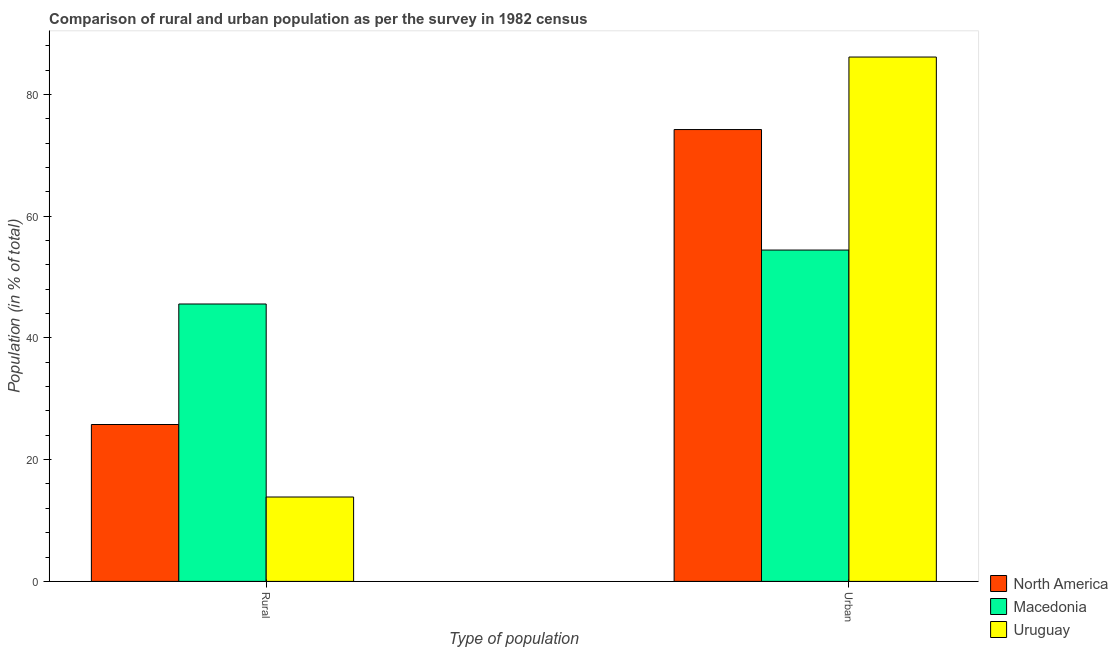How many different coloured bars are there?
Your response must be concise. 3. How many groups of bars are there?
Ensure brevity in your answer.  2. Are the number of bars on each tick of the X-axis equal?
Make the answer very short. Yes. How many bars are there on the 1st tick from the right?
Provide a succinct answer. 3. What is the label of the 1st group of bars from the left?
Your answer should be very brief. Rural. What is the rural population in Uruguay?
Keep it short and to the point. 13.86. Across all countries, what is the maximum rural population?
Offer a terse response. 45.57. Across all countries, what is the minimum rural population?
Provide a succinct answer. 13.86. In which country was the rural population maximum?
Your response must be concise. Macedonia. In which country was the rural population minimum?
Provide a short and direct response. Uruguay. What is the total urban population in the graph?
Make the answer very short. 214.8. What is the difference between the urban population in Uruguay and that in North America?
Offer a terse response. 11.91. What is the difference between the rural population in North America and the urban population in Uruguay?
Give a very brief answer. -60.37. What is the average urban population per country?
Provide a succinct answer. 71.6. What is the difference between the urban population and rural population in North America?
Provide a succinct answer. 48.45. What is the ratio of the urban population in North America to that in Macedonia?
Provide a succinct answer. 1.36. Is the urban population in Uruguay less than that in North America?
Offer a terse response. No. In how many countries, is the urban population greater than the average urban population taken over all countries?
Provide a succinct answer. 2. What does the 3rd bar from the left in Rural represents?
Offer a very short reply. Uruguay. What does the 3rd bar from the right in Urban represents?
Offer a very short reply. North America. How many bars are there?
Ensure brevity in your answer.  6. How many countries are there in the graph?
Provide a succinct answer. 3. Are the values on the major ticks of Y-axis written in scientific E-notation?
Offer a very short reply. No. Does the graph contain any zero values?
Give a very brief answer. No. How many legend labels are there?
Ensure brevity in your answer.  3. What is the title of the graph?
Ensure brevity in your answer.  Comparison of rural and urban population as per the survey in 1982 census. What is the label or title of the X-axis?
Provide a succinct answer. Type of population. What is the label or title of the Y-axis?
Offer a terse response. Population (in % of total). What is the Population (in % of total) in North America in Rural?
Offer a very short reply. 25.77. What is the Population (in % of total) in Macedonia in Rural?
Offer a terse response. 45.57. What is the Population (in % of total) of Uruguay in Rural?
Make the answer very short. 13.86. What is the Population (in % of total) in North America in Urban?
Your response must be concise. 74.23. What is the Population (in % of total) of Macedonia in Urban?
Give a very brief answer. 54.43. What is the Population (in % of total) in Uruguay in Urban?
Make the answer very short. 86.14. Across all Type of population, what is the maximum Population (in % of total) of North America?
Ensure brevity in your answer.  74.23. Across all Type of population, what is the maximum Population (in % of total) in Macedonia?
Provide a short and direct response. 54.43. Across all Type of population, what is the maximum Population (in % of total) in Uruguay?
Give a very brief answer. 86.14. Across all Type of population, what is the minimum Population (in % of total) in North America?
Provide a succinct answer. 25.77. Across all Type of population, what is the minimum Population (in % of total) in Macedonia?
Your answer should be very brief. 45.57. Across all Type of population, what is the minimum Population (in % of total) of Uruguay?
Your answer should be very brief. 13.86. What is the difference between the Population (in % of total) in North America in Rural and that in Urban?
Provide a succinct answer. -48.45. What is the difference between the Population (in % of total) in Macedonia in Rural and that in Urban?
Make the answer very short. -8.86. What is the difference between the Population (in % of total) in Uruguay in Rural and that in Urban?
Offer a very short reply. -72.28. What is the difference between the Population (in % of total) of North America in Rural and the Population (in % of total) of Macedonia in Urban?
Provide a succinct answer. -28.66. What is the difference between the Population (in % of total) in North America in Rural and the Population (in % of total) in Uruguay in Urban?
Provide a succinct answer. -60.37. What is the difference between the Population (in % of total) of Macedonia in Rural and the Population (in % of total) of Uruguay in Urban?
Ensure brevity in your answer.  -40.57. What is the average Population (in % of total) of Macedonia per Type of population?
Your answer should be compact. 50. What is the difference between the Population (in % of total) of North America and Population (in % of total) of Macedonia in Rural?
Make the answer very short. -19.8. What is the difference between the Population (in % of total) in North America and Population (in % of total) in Uruguay in Rural?
Your answer should be compact. 11.91. What is the difference between the Population (in % of total) of Macedonia and Population (in % of total) of Uruguay in Rural?
Offer a terse response. 31.71. What is the difference between the Population (in % of total) in North America and Population (in % of total) in Macedonia in Urban?
Offer a very short reply. 19.8. What is the difference between the Population (in % of total) in North America and Population (in % of total) in Uruguay in Urban?
Ensure brevity in your answer.  -11.91. What is the difference between the Population (in % of total) in Macedonia and Population (in % of total) in Uruguay in Urban?
Your response must be concise. -31.71. What is the ratio of the Population (in % of total) of North America in Rural to that in Urban?
Your answer should be compact. 0.35. What is the ratio of the Population (in % of total) in Macedonia in Rural to that in Urban?
Keep it short and to the point. 0.84. What is the ratio of the Population (in % of total) in Uruguay in Rural to that in Urban?
Ensure brevity in your answer.  0.16. What is the difference between the highest and the second highest Population (in % of total) of North America?
Give a very brief answer. 48.45. What is the difference between the highest and the second highest Population (in % of total) of Macedonia?
Offer a very short reply. 8.86. What is the difference between the highest and the second highest Population (in % of total) of Uruguay?
Provide a short and direct response. 72.28. What is the difference between the highest and the lowest Population (in % of total) in North America?
Offer a terse response. 48.45. What is the difference between the highest and the lowest Population (in % of total) of Macedonia?
Your answer should be very brief. 8.86. What is the difference between the highest and the lowest Population (in % of total) of Uruguay?
Ensure brevity in your answer.  72.28. 